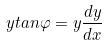Convert formula to latex. <formula><loc_0><loc_0><loc_500><loc_500>y t a n \varphi = y \frac { d y } { d x }</formula> 